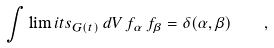Convert formula to latex. <formula><loc_0><loc_0><loc_500><loc_500>\int \lim i t s _ { G ( t ) } \, d V \, f _ { \alpha } \, f _ { \beta } = \delta ( \alpha , \beta ) \quad ,</formula> 